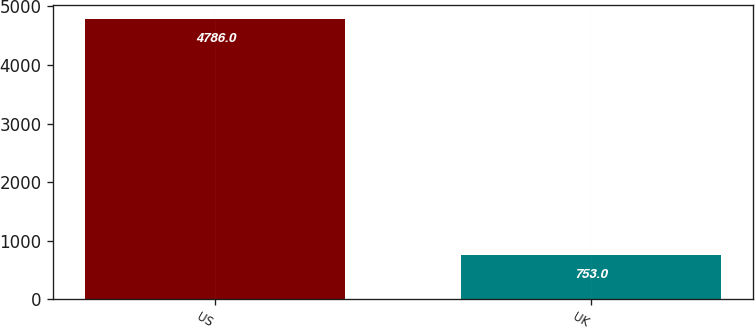Convert chart to OTSL. <chart><loc_0><loc_0><loc_500><loc_500><bar_chart><fcel>US<fcel>UK<nl><fcel>4786<fcel>753<nl></chart> 